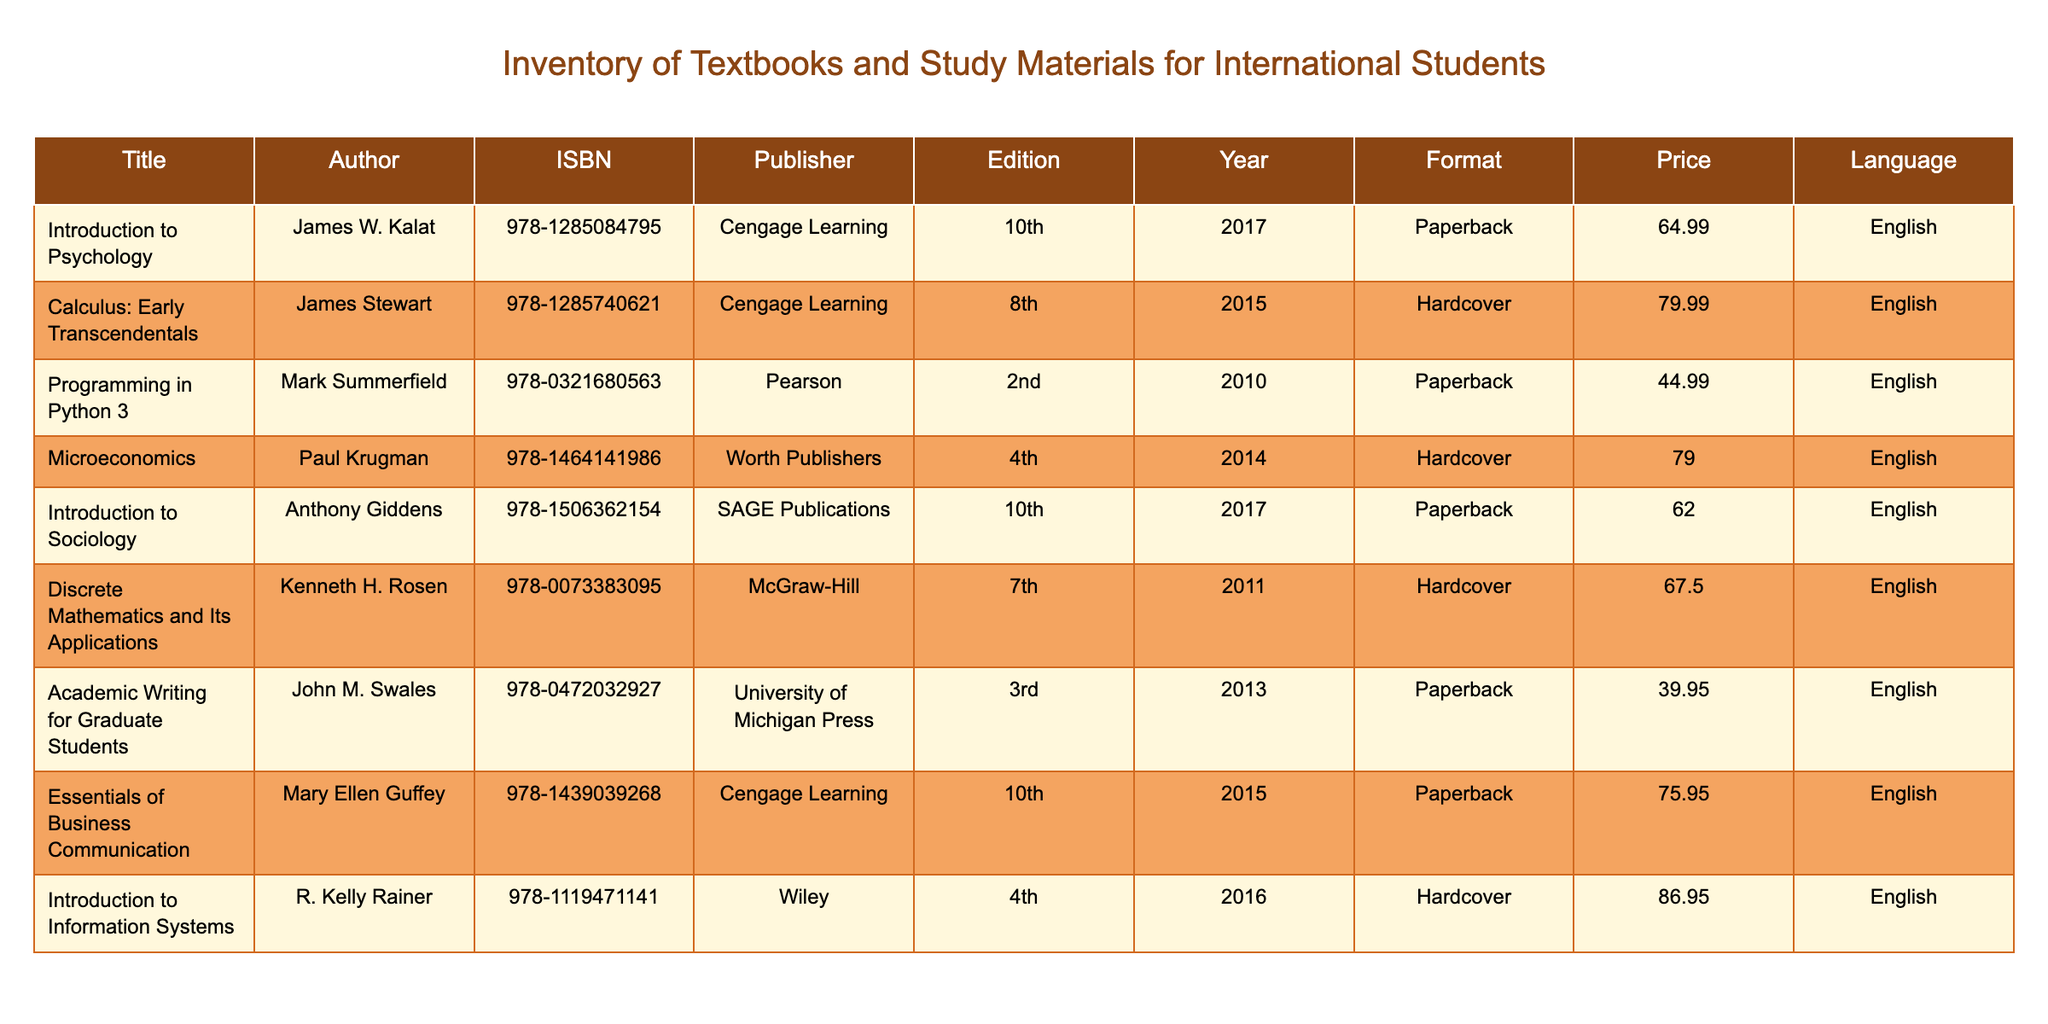What is the price of "Programming in Python 3"? The price of "Programming in Python 3", as listed in the table, is 44.99.
Answer: 44.99 What is the title of the book by James Stewart? The book by James Stewart in the table is titled "Calculus: Early Transcendentals".
Answer: "Calculus: Early Transcendentals" How many textbooks are published by Cengage Learning? By looking at the publisher column, there are three textbooks published by Cengage Learning: "Introduction to Psychology", "Calculus: Early Transcendentals", and "Essentials of Business Communication".
Answer: 3 Which book has the highest price? To find the book with the highest price, we compare the prices in the table. "Introduction to Information Systems" is listed at 86.95, which is the highest among all the entries.
Answer: "Introduction to Information Systems" Is "Introduction to Sociology" available in paperback? The format column indicates that "Introduction to Sociology" is indeed listed as a paperback.
Answer: Yes What is the total price of all hardcover books in the inventory? The prices of the hardcover books in the table are: "Calculus: Early Transcendentals" for 79.99, "Microeconomics" for 79.00, "Discrete Mathematics and Its Applications" for 67.50, and "Introduction to Information Systems" for 86.95. Summing these prices gives: 79.99 + 79.00 + 67.50 + 86.95 = 313.44.
Answer: 313.44 What percentage of the textbooks are in English? All the textbooks in the provided table are in English. Thus, 100% of them are in English. Since there are 9 entries, the calculation is (9/9) * 100 = 100%.
Answer: 100% Which author has written more than one book in the inventory? By checking the author column, it appears that no author is listed with more than one book in the inventory. Each author has only authored one book shown in the table.
Answer: No What is the median price of all textbooks in the inventory? To find the median, we first list all the prices: 64.99, 79.99, 44.99, 79.00, 62.00, 67.50, 39.95, 75.95, 86.95. After sorting these prices, we get: 39.95, 44.99, 62.00, 64.99, 67.50, 75.95, 79.00, 79.99, 86.95. The median is the middle value, which is 67.50.
Answer: 67.50 